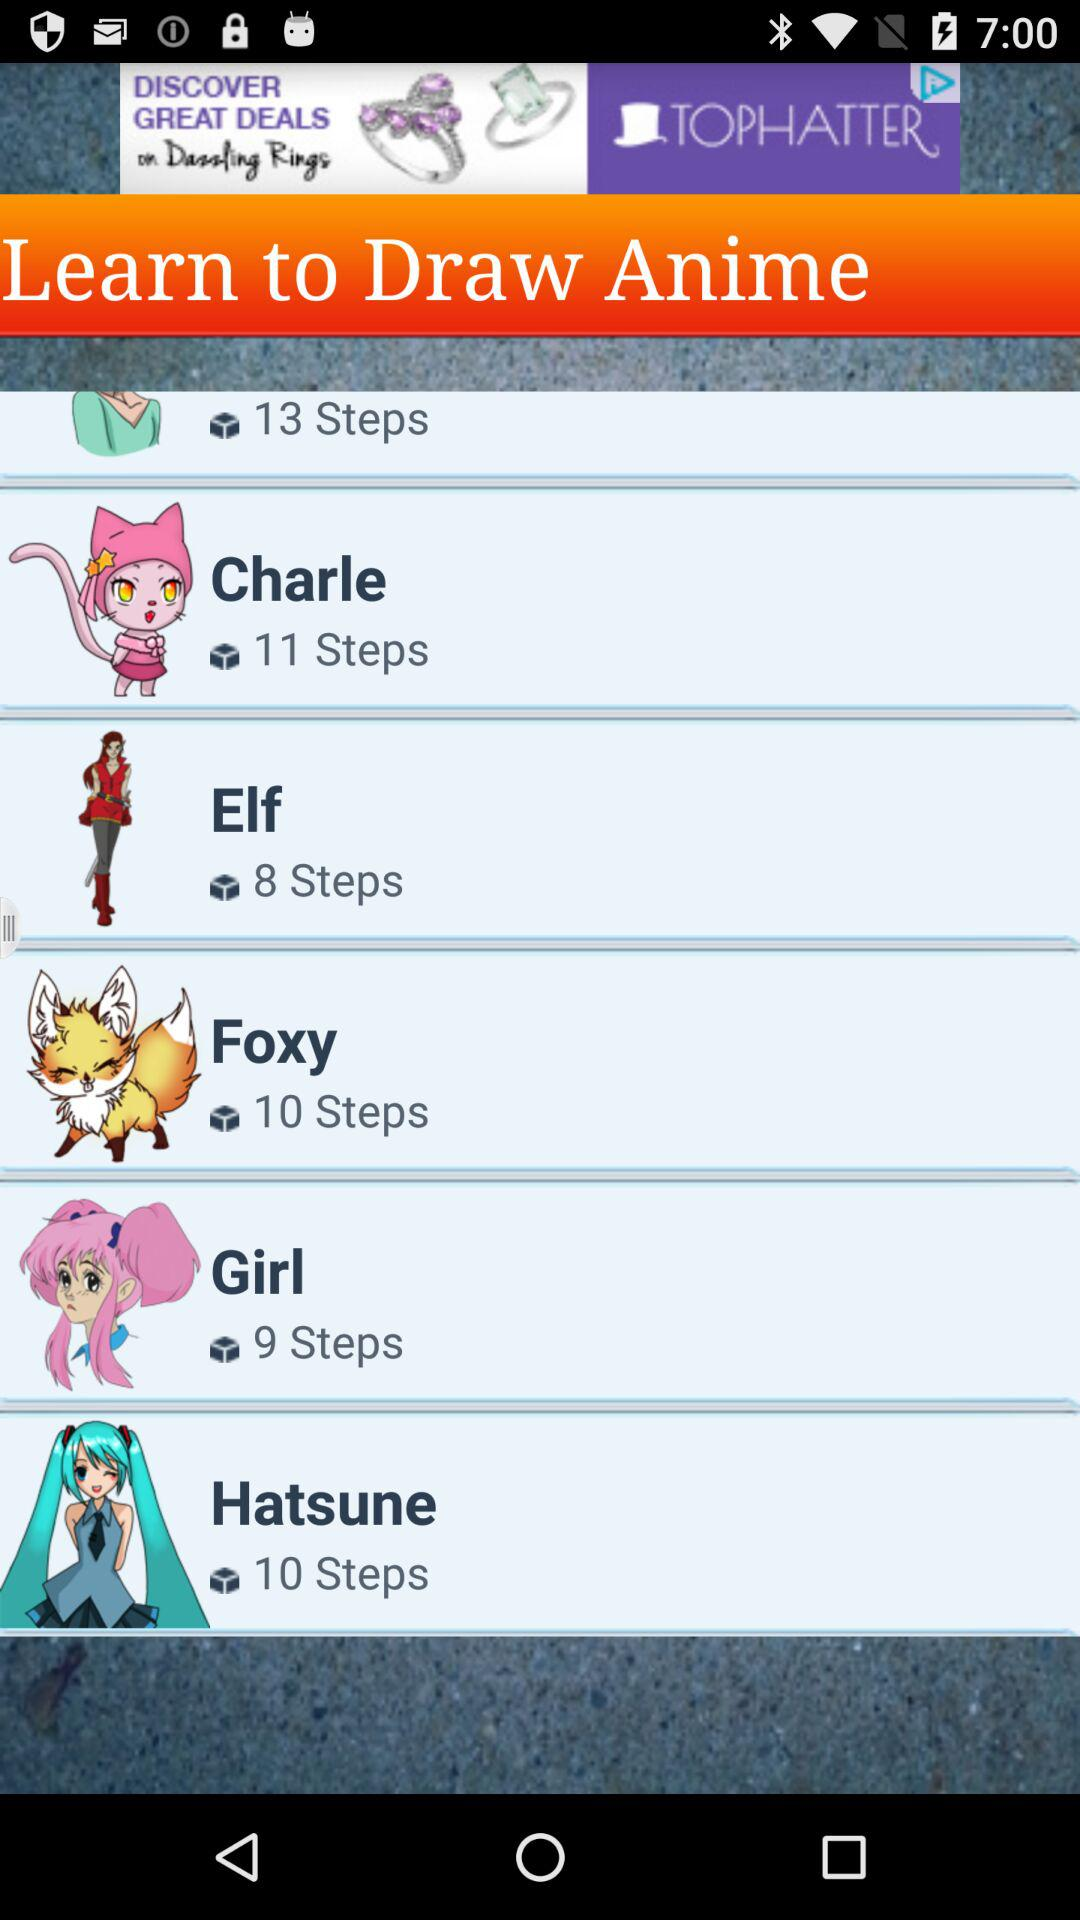How many steps are there in "Charle"? There are 11 steps in "Charle". 